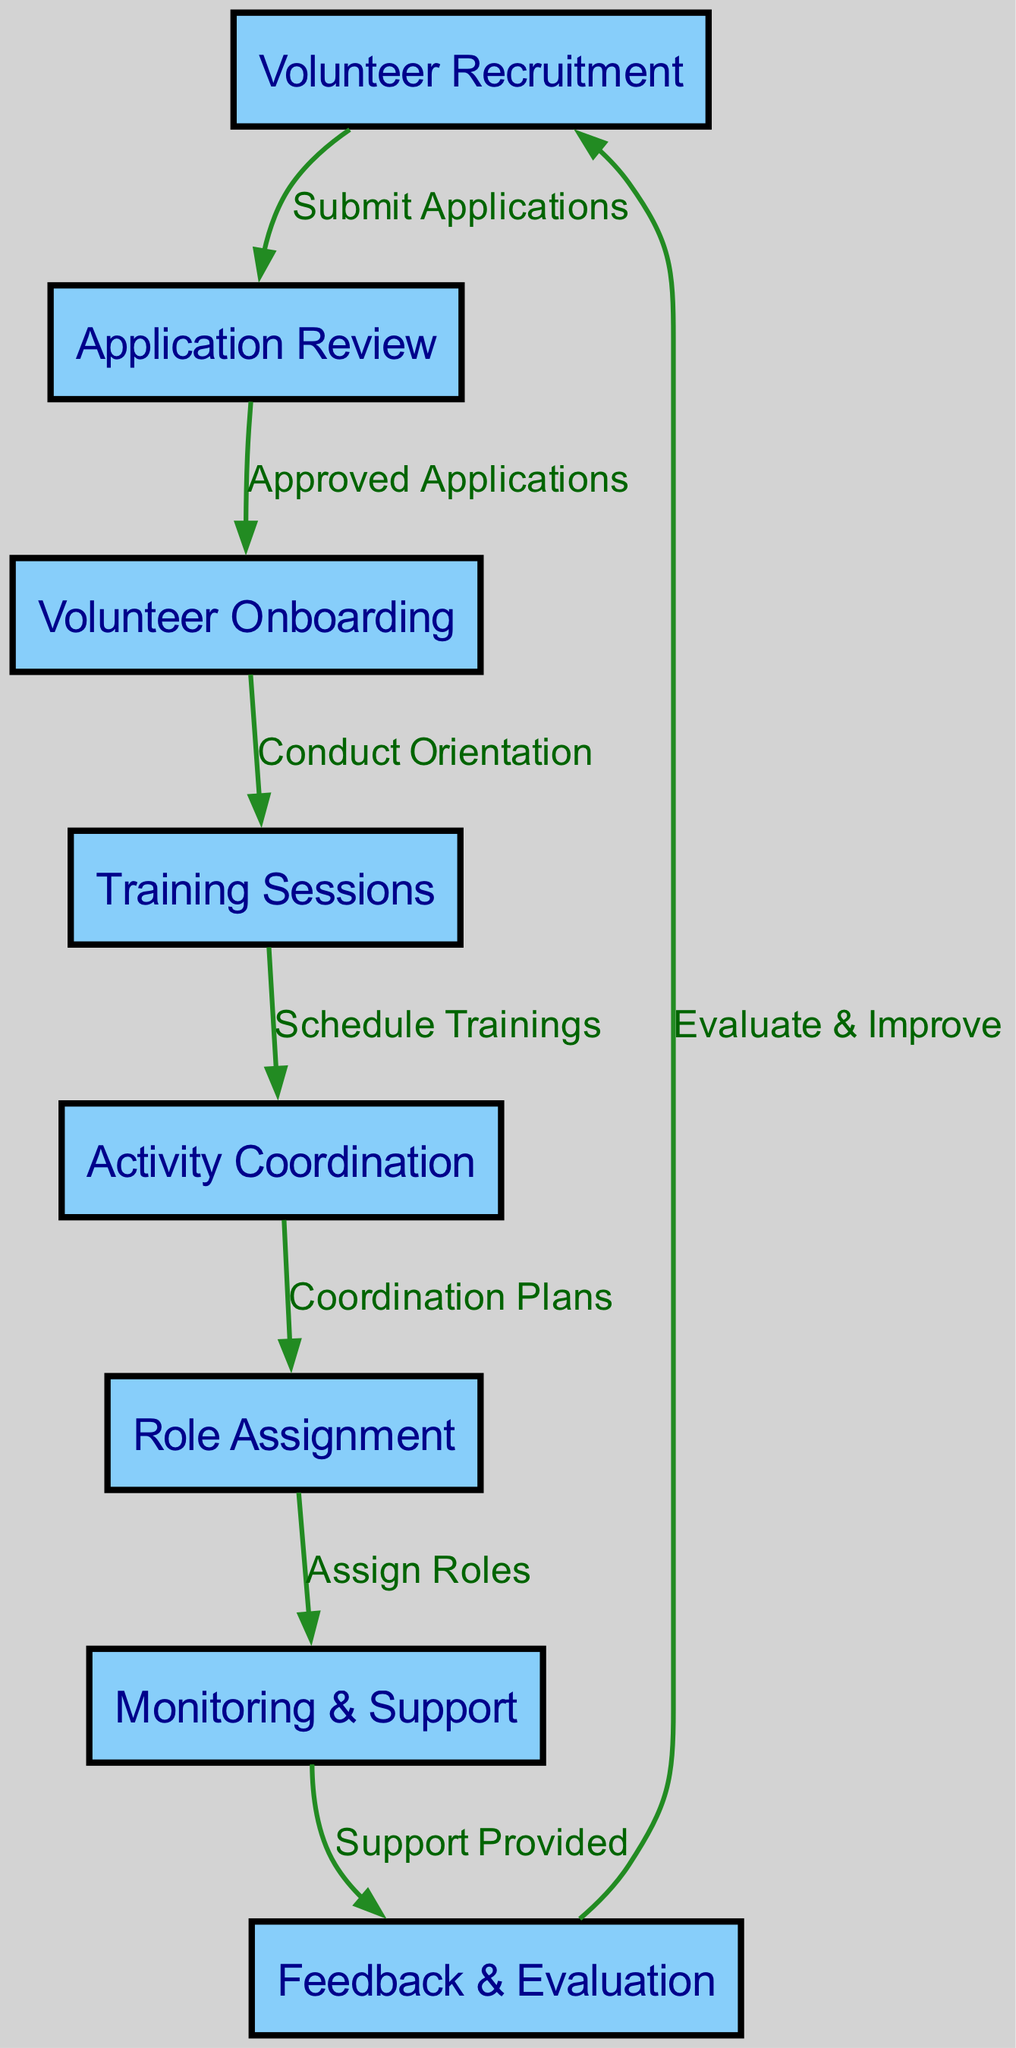What is the first step in the volunteer coordination process? The first node in the diagram is "Volunteer Recruitment," which indicates the first step in this process.
Answer: Volunteer Recruitment How many nodes are present in the diagram? The diagram contains a total of eight nodes, which represent different activities in the volunteer coordination process.
Answer: 8 What does the edge from "Training Sessions" to "Activity Coordination" represent? This edge labeled "Schedule Trainings" shows the relationship that after training sessions take place, the next activity is to coordinate volunteer activities.
Answer: Schedule Trainings Which node follows "Application Review"? The edge labeled "Approved Applications" connects "Application Review" to "Volunteer Onboarding," indicating that the next step is "Volunteer Onboarding."
Answer: Volunteer Onboarding What is the final activity in the volunteer flowchart? The last node before the flow concludes is "Feedback & Evaluation," which connects back to the "Volunteer Recruitment" node for continuous improvement.
Answer: Feedback & Evaluation How does the "Monitoring & Support" phase relate to "Role Assignment"? The edge labeled "Assign Roles" indicates that roles are assigned during the "Monitoring & Support" phase, further showcasing the structured flow between these two activities.
Answer: Assign Roles What action does "Feedback & Evaluation" prompt in the diagram? The edge labeled "Evaluate & Improve" indicates that the actions taken in this phase lead back to the "Volunteer Recruitment" phase to enhance future volunteer recruitment processes.
Answer: Evaluate & Improve What type of diagram is this? The diagram represents a flowchart specifically designed for coordinating volunteer activities, showcasing the sequential processes and responsibilities.
Answer: Flowchart 